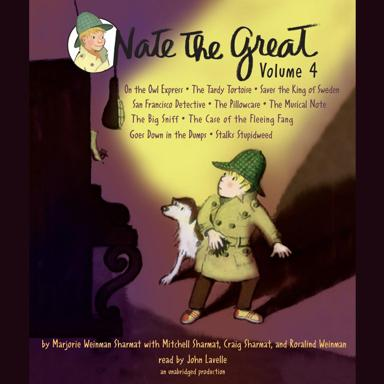Who are the authors of these stories? The stories in 'Nate The Great Volume 4' are written by Marjorie Weinman Sharmat and Mitchell Sharmat. They often collaborate on the Nate the Great series, known for its engaging narrative style that appeals to children. 